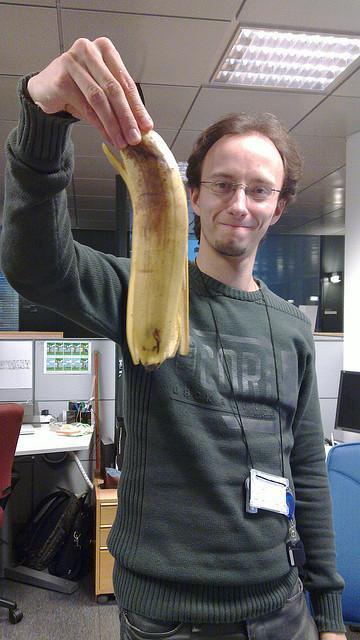How many chairs are there?
Give a very brief answer. 1. How many backpacks are there?
Give a very brief answer. 2. How many levels does the bus have?
Give a very brief answer. 0. 